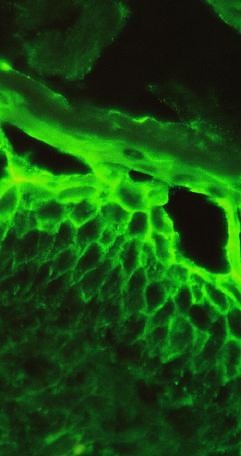what are immunoglobulin deposits confined to?
Answer the question using a single word or phrase. Superficial layers of the epidermis 